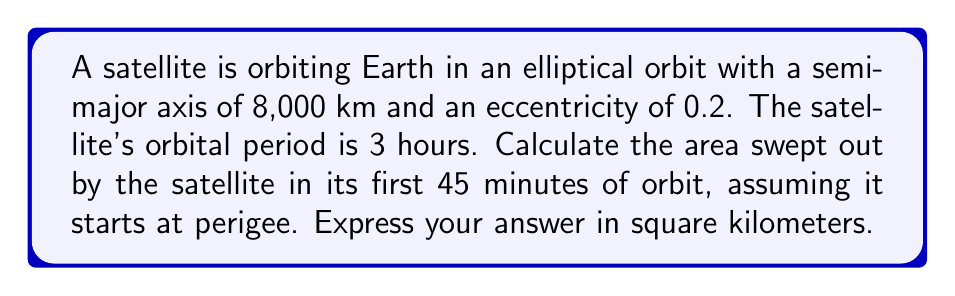Can you solve this math problem? Let's approach this step-by-step:

1) First, we need to recall Kepler's Second Law, which states that a line segment joining a planet and the Sun sweeps out equal areas during equal intervals of time. This applies to any elliptical orbit, including our satellite's orbit around Earth.

2) The area of the entire ellipse is given by $A = \pi ab$, where $a$ is the semi-major axis and $b$ is the semi-minor axis.

3) We know $a = 8,000$ km. To find $b$, we use the eccentricity formula:
   $e = \sqrt{1 - (\frac{b}{a})^2}$
   $0.2 = \sqrt{1 - (\frac{b}{8000})^2}$
   Solving this: $b \approx 7,832.97$ km

4) Now we can calculate the total area:
   $A = \pi ab = \pi(8000)(7832.97) \approx 196,349,785$ km²

5) The satellite completes one orbit in 3 hours. In 45 minutes, it completes $\frac{45}{180} = \frac{1}{4}$ of its orbit.

6) Therefore, the area swept out in 45 minutes is $\frac{1}{4}$ of the total area:
   $\frac{1}{4} \times 196,349,785 \approx 49,087,446$ km²

This method uses the properties of ellipses and Kepler's laws, which are fundamental in astrophysics for understanding orbital mechanics.
Answer: The area swept out by the satellite in its first 45 minutes of orbit is approximately 49,087,446 km². 